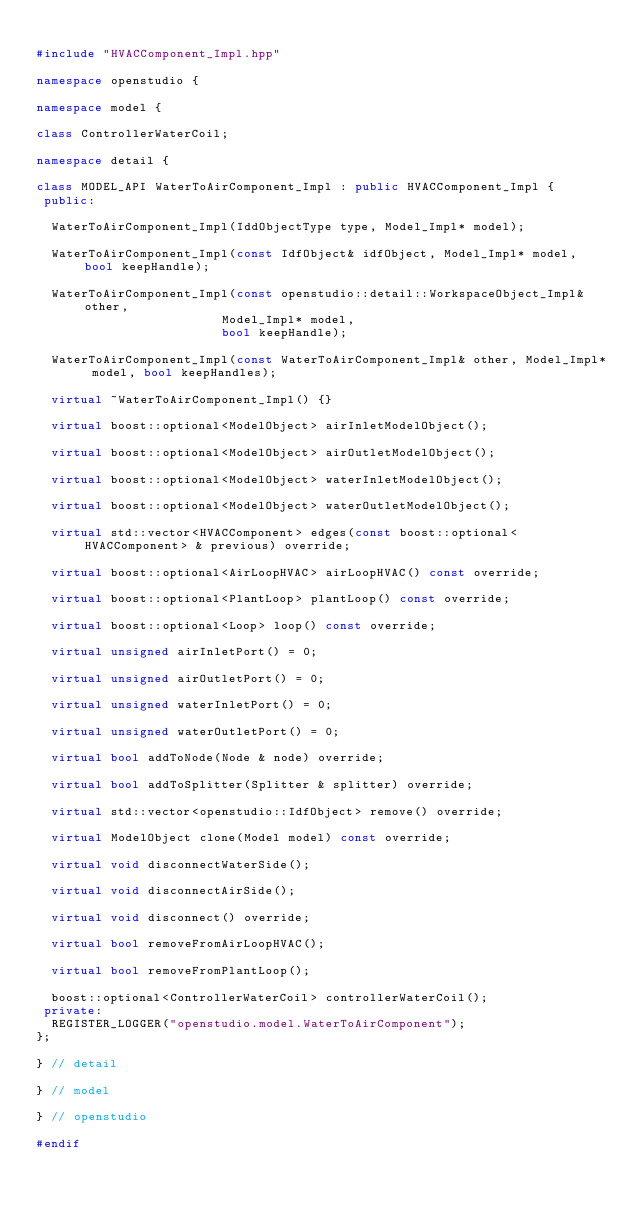Convert code to text. <code><loc_0><loc_0><loc_500><loc_500><_C++_>
#include "HVACComponent_Impl.hpp"

namespace openstudio {

namespace model {

class ControllerWaterCoil;

namespace detail {

class MODEL_API WaterToAirComponent_Impl : public HVACComponent_Impl {
 public:

  WaterToAirComponent_Impl(IddObjectType type, Model_Impl* model);

  WaterToAirComponent_Impl(const IdfObject& idfObject, Model_Impl* model, bool keepHandle);

  WaterToAirComponent_Impl(const openstudio::detail::WorkspaceObject_Impl& other,
                         Model_Impl* model,
                         bool keepHandle);

  WaterToAirComponent_Impl(const WaterToAirComponent_Impl& other, Model_Impl* model, bool keepHandles);

  virtual ~WaterToAirComponent_Impl() {}

  virtual boost::optional<ModelObject> airInletModelObject();

  virtual boost::optional<ModelObject> airOutletModelObject();

  virtual boost::optional<ModelObject> waterInletModelObject();

  virtual boost::optional<ModelObject> waterOutletModelObject();

  virtual std::vector<HVACComponent> edges(const boost::optional<HVACComponent> & previous) override;

  virtual boost::optional<AirLoopHVAC> airLoopHVAC() const override;

  virtual boost::optional<PlantLoop> plantLoop() const override;

  virtual boost::optional<Loop> loop() const override;

  virtual unsigned airInletPort() = 0;

  virtual unsigned airOutletPort() = 0;

  virtual unsigned waterInletPort() = 0;

  virtual unsigned waterOutletPort() = 0;

  virtual bool addToNode(Node & node) override;

  virtual bool addToSplitter(Splitter & splitter) override;

  virtual std::vector<openstudio::IdfObject> remove() override;

  virtual ModelObject clone(Model model) const override;

  virtual void disconnectWaterSide();

  virtual void disconnectAirSide();

  virtual void disconnect() override;

  virtual bool removeFromAirLoopHVAC();

  virtual bool removeFromPlantLoop();

  boost::optional<ControllerWaterCoil> controllerWaterCoil();
 private:
  REGISTER_LOGGER("openstudio.model.WaterToAirComponent");
};

} // detail

} // model

} // openstudio

#endif

</code> 